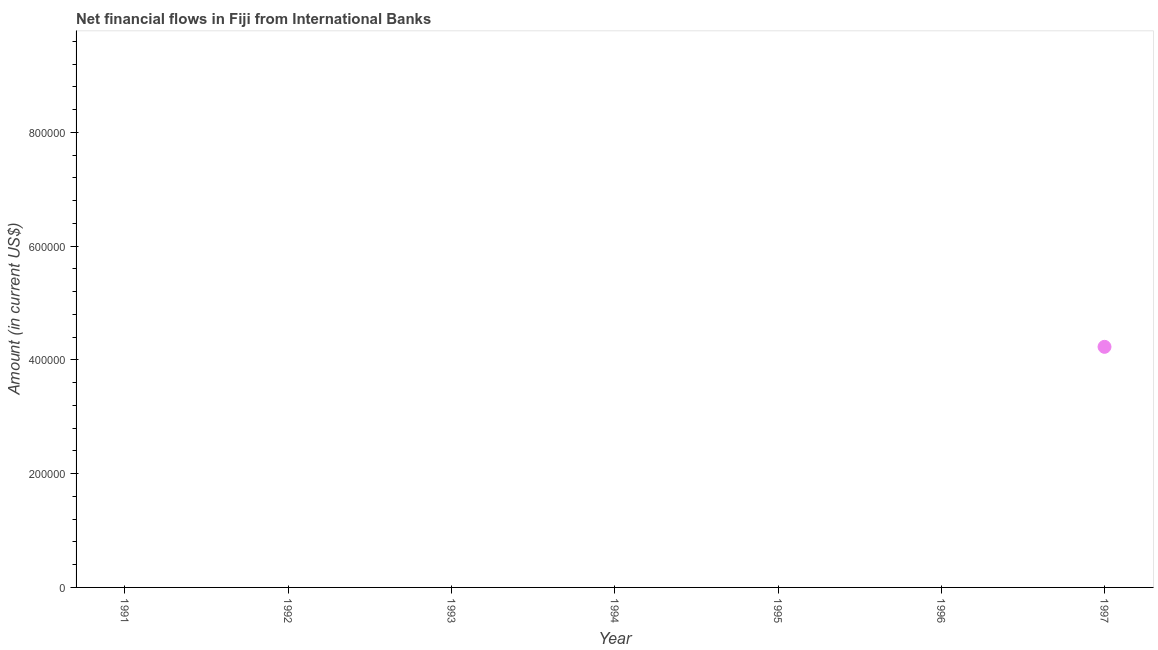Across all years, what is the maximum net financial flows from ibrd?
Make the answer very short. 4.23e+05. Across all years, what is the minimum net financial flows from ibrd?
Your answer should be very brief. 0. In which year was the net financial flows from ibrd maximum?
Provide a succinct answer. 1997. What is the sum of the net financial flows from ibrd?
Provide a short and direct response. 4.23e+05. What is the average net financial flows from ibrd per year?
Keep it short and to the point. 6.04e+04. What is the median net financial flows from ibrd?
Give a very brief answer. 0. In how many years, is the net financial flows from ibrd greater than 200000 US$?
Provide a short and direct response. 1. What is the difference between the highest and the lowest net financial flows from ibrd?
Give a very brief answer. 4.23e+05. In how many years, is the net financial flows from ibrd greater than the average net financial flows from ibrd taken over all years?
Provide a short and direct response. 1. Does the net financial flows from ibrd monotonically increase over the years?
Offer a very short reply. No. How many dotlines are there?
Provide a succinct answer. 1. What is the difference between two consecutive major ticks on the Y-axis?
Offer a very short reply. 2.00e+05. Are the values on the major ticks of Y-axis written in scientific E-notation?
Provide a succinct answer. No. Does the graph contain any zero values?
Your response must be concise. Yes. Does the graph contain grids?
Give a very brief answer. No. What is the title of the graph?
Make the answer very short. Net financial flows in Fiji from International Banks. What is the label or title of the X-axis?
Keep it short and to the point. Year. What is the Amount (in current US$) in 1991?
Your answer should be very brief. 0. What is the Amount (in current US$) in 1995?
Ensure brevity in your answer.  0. What is the Amount (in current US$) in 1996?
Your answer should be compact. 0. What is the Amount (in current US$) in 1997?
Offer a very short reply. 4.23e+05. 